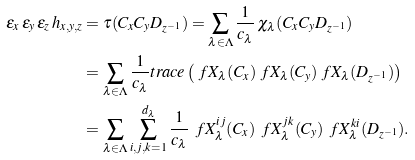Convert formula to latex. <formula><loc_0><loc_0><loc_500><loc_500>\varepsilon _ { x } \, \varepsilon _ { y } \, \varepsilon _ { z } \, h _ { x , y , z } & = \tau ( C _ { x } C _ { y } D _ { z ^ { - 1 } } ) = \sum _ { \lambda \in \Lambda } \frac { 1 } { c _ { \lambda } } \, \chi _ { \lambda } ( C _ { x } C _ { y } D _ { z ^ { - 1 } } ) \\ & = \sum _ { \lambda \in \Lambda } \frac { 1 } { c _ { \lambda } } t r a c e \left ( \ f X _ { \lambda } ( C _ { x } ) \ f X _ { \lambda } ( C _ { y } ) \ f X _ { \lambda } ( D _ { z ^ { - 1 } } ) \right ) \\ & = \sum _ { \lambda \in \Lambda } \sum _ { i , j , k = 1 } ^ { d _ { \lambda } } \frac { 1 } { c _ { \lambda } } \, \ f X _ { \lambda } ^ { i j } ( C _ { x } ) \, \ f X _ { \lambda } ^ { j k } ( C _ { y } ) \, \ f X _ { \lambda } ^ { k i } ( D _ { z ^ { - 1 } } ) .</formula> 